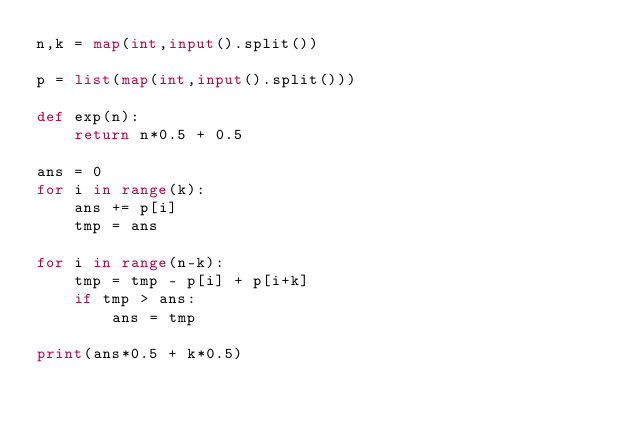Convert code to text. <code><loc_0><loc_0><loc_500><loc_500><_Python_>n,k = map(int,input().split())

p = list(map(int,input().split()))

def exp(n):
    return n*0.5 + 0.5

ans = 0
for i in range(k):
    ans += p[i]
    tmp = ans

for i in range(n-k):
    tmp = tmp - p[i] + p[i+k]
    if tmp > ans:
        ans = tmp

print(ans*0.5 + k*0.5)</code> 